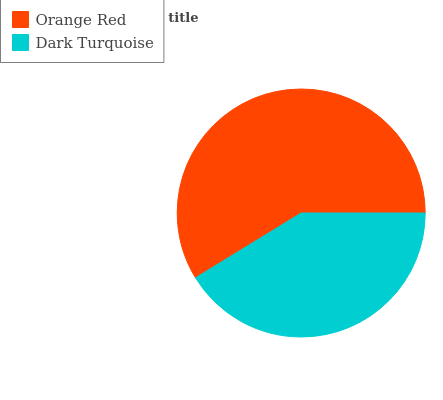Is Dark Turquoise the minimum?
Answer yes or no. Yes. Is Orange Red the maximum?
Answer yes or no. Yes. Is Dark Turquoise the maximum?
Answer yes or no. No. Is Orange Red greater than Dark Turquoise?
Answer yes or no. Yes. Is Dark Turquoise less than Orange Red?
Answer yes or no. Yes. Is Dark Turquoise greater than Orange Red?
Answer yes or no. No. Is Orange Red less than Dark Turquoise?
Answer yes or no. No. Is Orange Red the high median?
Answer yes or no. Yes. Is Dark Turquoise the low median?
Answer yes or no. Yes. Is Dark Turquoise the high median?
Answer yes or no. No. Is Orange Red the low median?
Answer yes or no. No. 